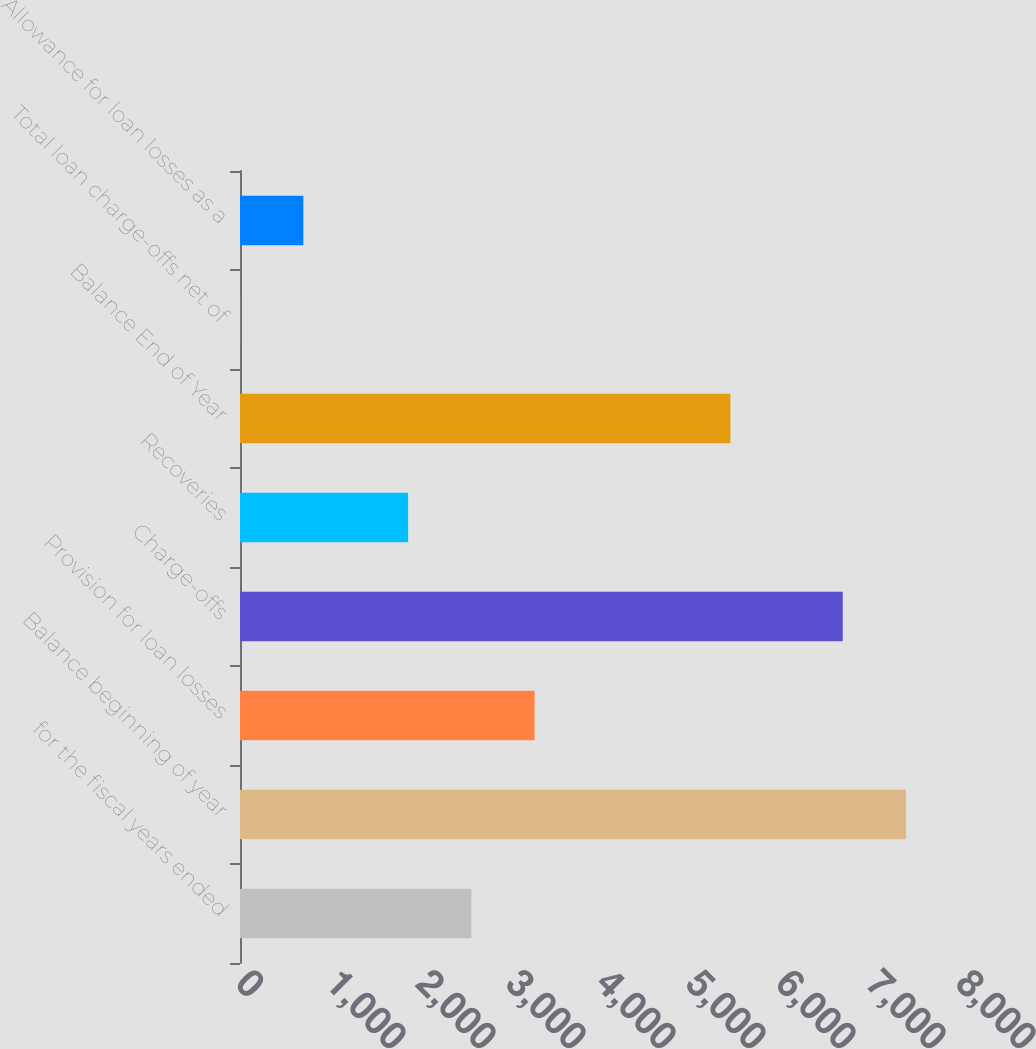Convert chart to OTSL. <chart><loc_0><loc_0><loc_500><loc_500><bar_chart><fcel>for the fiscal years ended<fcel>Balance beginning of year<fcel>Provision for loan losses<fcel>Charge-offs<fcel>Recoveries<fcel>Balance End of Year<fcel>Total loan charge-offs net of<fcel>Allowance for loan losses as a<nl><fcel>2570.47<fcel>7399.47<fcel>3272.94<fcel>6697<fcel>1868<fcel>5449<fcel>1.31<fcel>703.78<nl></chart> 